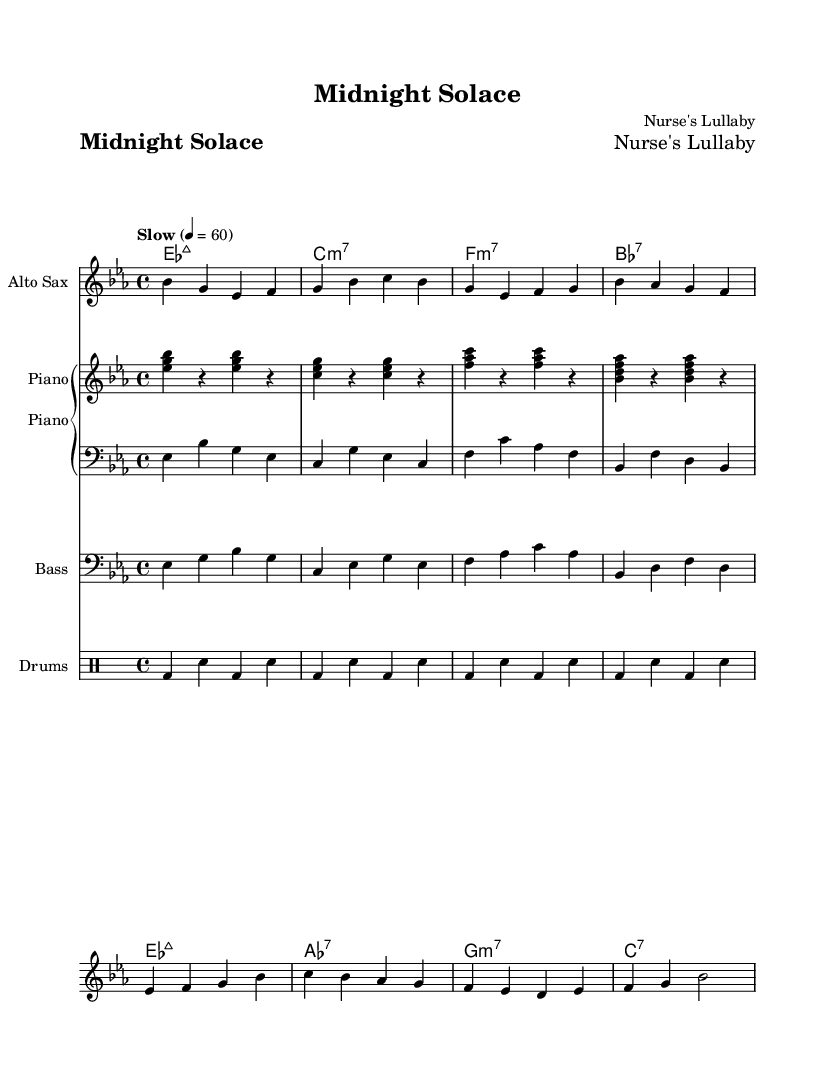What is the key signature of this music? The key signature is represented by the sharps or flats indicated in the music. Here, there are three flats shown in the key signature, which corresponds to E flat major.
Answer: E flat major What is the time signature of the piece? The time signature is displayed at the beginning of the music. In this sheet music, it shows 4/4, indicating there are four beats in each measure.
Answer: 4/4 What is the tempo marking for this piece? The tempo marking is indicated in the score, and it specifies the speed at which the piece should be played. Here, it states "Slow" with a tempo of 60 beats per minute, suggesting a relaxed pace.
Answer: Slow How many measures does the melody span? To determine the number of measures in the melody, you'll count the vertical lines or bar lines that separate the measures. In this piece, there are eight measures in total.
Answer: Eight measures What are the primary instruments in this arrangement? The primary instruments are listed at the beginning of each staff. This music features Alto Sax, Piano, Bass, and Drums as the main instruments.
Answer: Alto Sax, Piano, Bass, Drums What type of harmony is predominantly used in this jazz piece? The harmony can be inferred from the chord symbols shown above the melody. The piece uses mostly seventh chords, which is characteristic of jazz music.
Answer: Seventh chords What is the name of this composition? The title of the piece is indicated at the top of the sheet music. In this case, it is titled "Midnight Solace."
Answer: Midnight Solace 